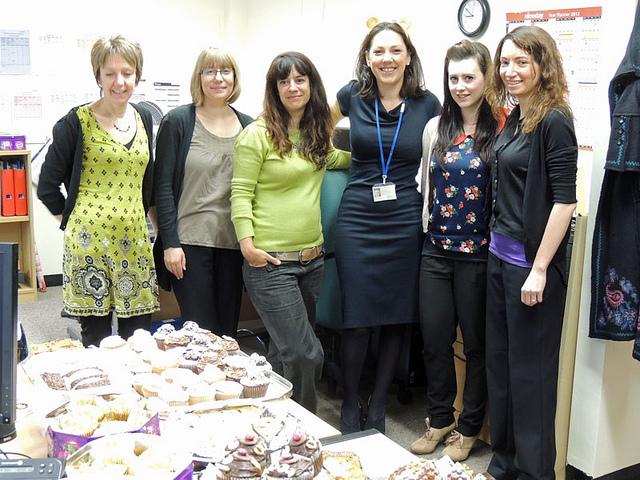How many women are standing?
Give a very brief answer. 6. How many people are in the photo?
Give a very brief answer. 6. Are the people in the photo sad?
Keep it brief. No. 